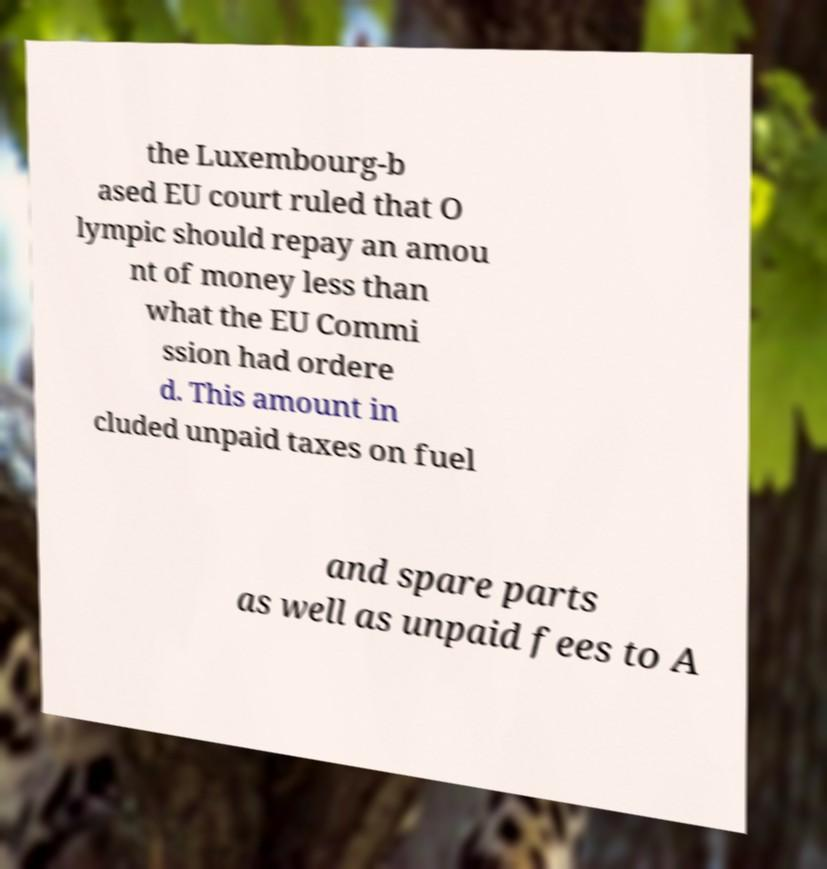Could you extract and type out the text from this image? the Luxembourg-b ased EU court ruled that O lympic should repay an amou nt of money less than what the EU Commi ssion had ordere d. This amount in cluded unpaid taxes on fuel and spare parts as well as unpaid fees to A 